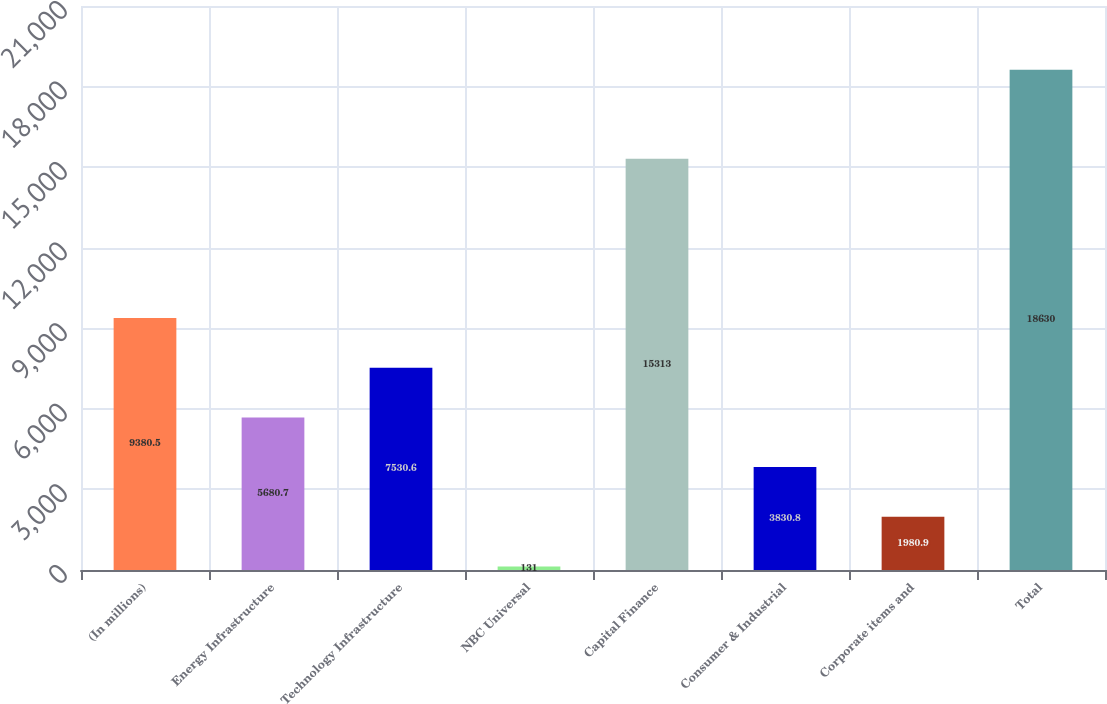<chart> <loc_0><loc_0><loc_500><loc_500><bar_chart><fcel>(In millions)<fcel>Energy Infrastructure<fcel>Technology Infrastructure<fcel>NBC Universal<fcel>Capital Finance<fcel>Consumer & Industrial<fcel>Corporate items and<fcel>Total<nl><fcel>9380.5<fcel>5680.7<fcel>7530.6<fcel>131<fcel>15313<fcel>3830.8<fcel>1980.9<fcel>18630<nl></chart> 